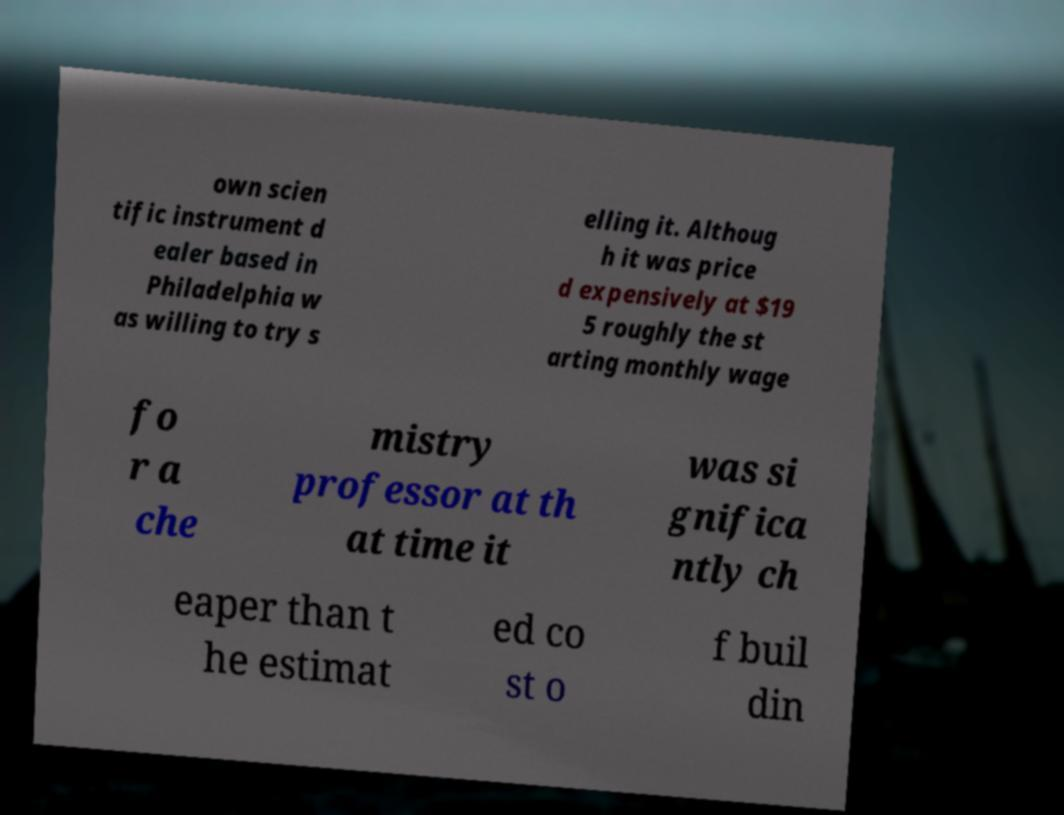Can you accurately transcribe the text from the provided image for me? own scien tific instrument d ealer based in Philadelphia w as willing to try s elling it. Althoug h it was price d expensively at $19 5 roughly the st arting monthly wage fo r a che mistry professor at th at time it was si gnifica ntly ch eaper than t he estimat ed co st o f buil din 